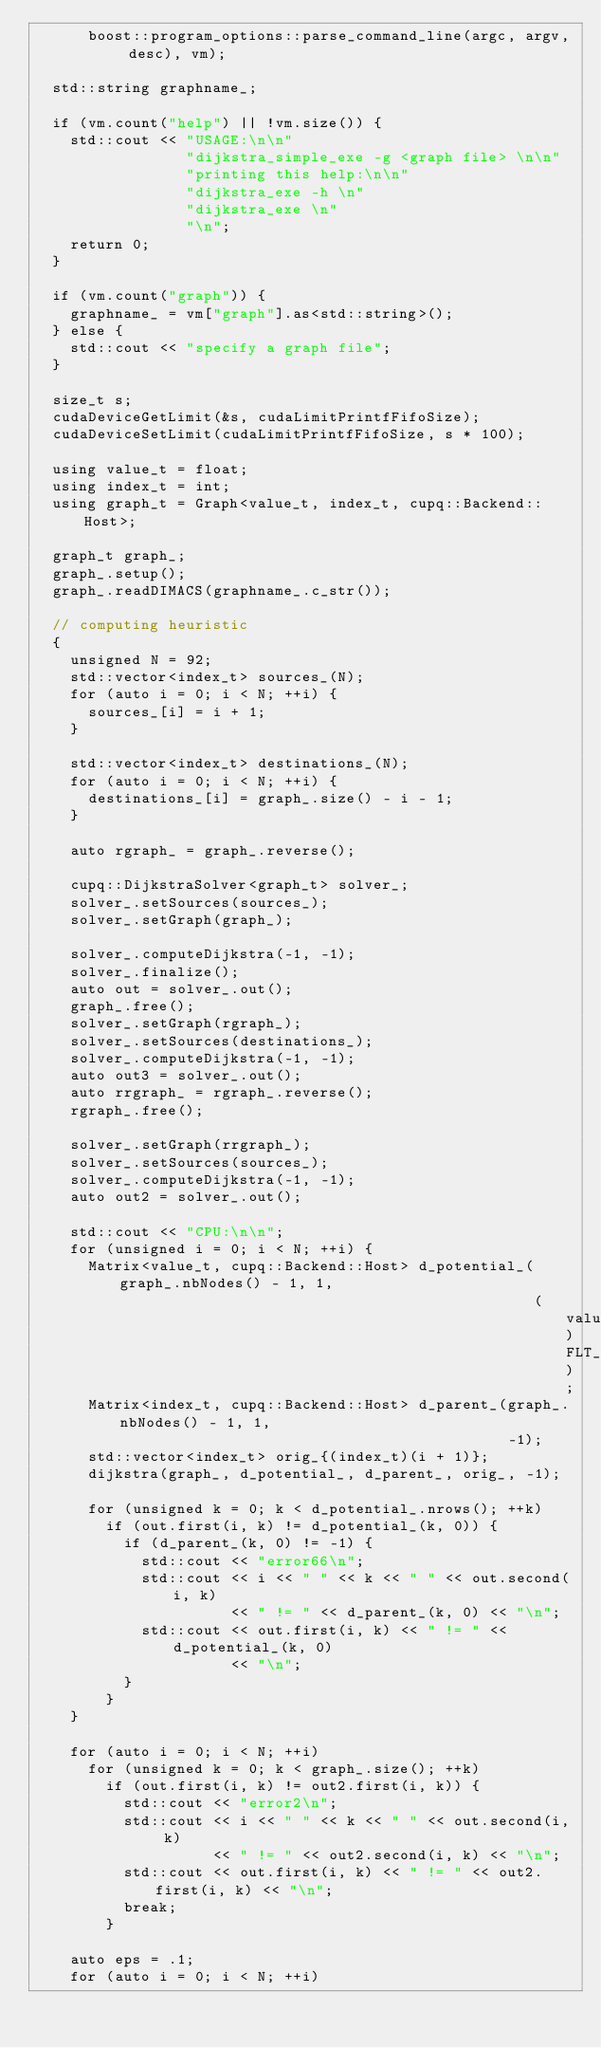Convert code to text. <code><loc_0><loc_0><loc_500><loc_500><_Cuda_>      boost::program_options::parse_command_line(argc, argv, desc), vm);

  std::string graphname_;

  if (vm.count("help") || !vm.size()) {
    std::cout << "USAGE:\n\n"
                 "dijkstra_simple_exe -g <graph file> \n\n"
                 "printing this help:\n\n"
                 "dijkstra_exe -h \n"
                 "dijkstra_exe \n"
                 "\n";
    return 0;
  }

  if (vm.count("graph")) {
    graphname_ = vm["graph"].as<std::string>();
  } else {
    std::cout << "specify a graph file";
  }

  size_t s;
  cudaDeviceGetLimit(&s, cudaLimitPrintfFifoSize);
  cudaDeviceSetLimit(cudaLimitPrintfFifoSize, s * 100);

  using value_t = float;
  using index_t = int;
  using graph_t = Graph<value_t, index_t, cupq::Backend::Host>;

  graph_t graph_;
  graph_.setup();
  graph_.readDIMACS(graphname_.c_str());

  // computing heuristic
  {
    unsigned N = 92;
    std::vector<index_t> sources_(N);
    for (auto i = 0; i < N; ++i) {
      sources_[i] = i + 1;
    }

    std::vector<index_t> destinations_(N);
    for (auto i = 0; i < N; ++i) {
      destinations_[i] = graph_.size() - i - 1;
    }

    auto rgraph_ = graph_.reverse();

    cupq::DijkstraSolver<graph_t> solver_;
    solver_.setSources(sources_);
    solver_.setGraph(graph_);

    solver_.computeDijkstra(-1, -1);
    solver_.finalize();
    auto out = solver_.out();
    graph_.free();
    solver_.setGraph(rgraph_);
    solver_.setSources(destinations_);
    solver_.computeDijkstra(-1, -1);
    auto out3 = solver_.out();
    auto rrgraph_ = rgraph_.reverse();
    rgraph_.free();

    solver_.setGraph(rrgraph_);
    solver_.setSources(sources_);
    solver_.computeDijkstra(-1, -1);
    auto out2 = solver_.out();

    std::cout << "CPU:\n\n";
    for (unsigned i = 0; i < N; ++i) {
      Matrix<value_t, cupq::Backend::Host> d_potential_(graph_.nbNodes() - 1, 1,
                                                        (value_t)FLT_MAX);
      Matrix<index_t, cupq::Backend::Host> d_parent_(graph_.nbNodes() - 1, 1,
                                                     -1);
      std::vector<index_t> orig_{(index_t)(i + 1)};
      dijkstra(graph_, d_potential_, d_parent_, orig_, -1);

      for (unsigned k = 0; k < d_potential_.nrows(); ++k)
        if (out.first(i, k) != d_potential_(k, 0)) {
          if (d_parent_(k, 0) != -1) {
            std::cout << "error66\n";
            std::cout << i << " " << k << " " << out.second(i, k)
                      << " != " << d_parent_(k, 0) << "\n";
            std::cout << out.first(i, k) << " != " << d_potential_(k, 0)
                      << "\n";
          }
        }
    }

    for (auto i = 0; i < N; ++i)
      for (unsigned k = 0; k < graph_.size(); ++k)
        if (out.first(i, k) != out2.first(i, k)) {
          std::cout << "error2\n";
          std::cout << i << " " << k << " " << out.second(i, k)
                    << " != " << out2.second(i, k) << "\n";
          std::cout << out.first(i, k) << " != " << out2.first(i, k) << "\n";
          break;
        }

    auto eps = .1;
    for (auto i = 0; i < N; ++i)</code> 